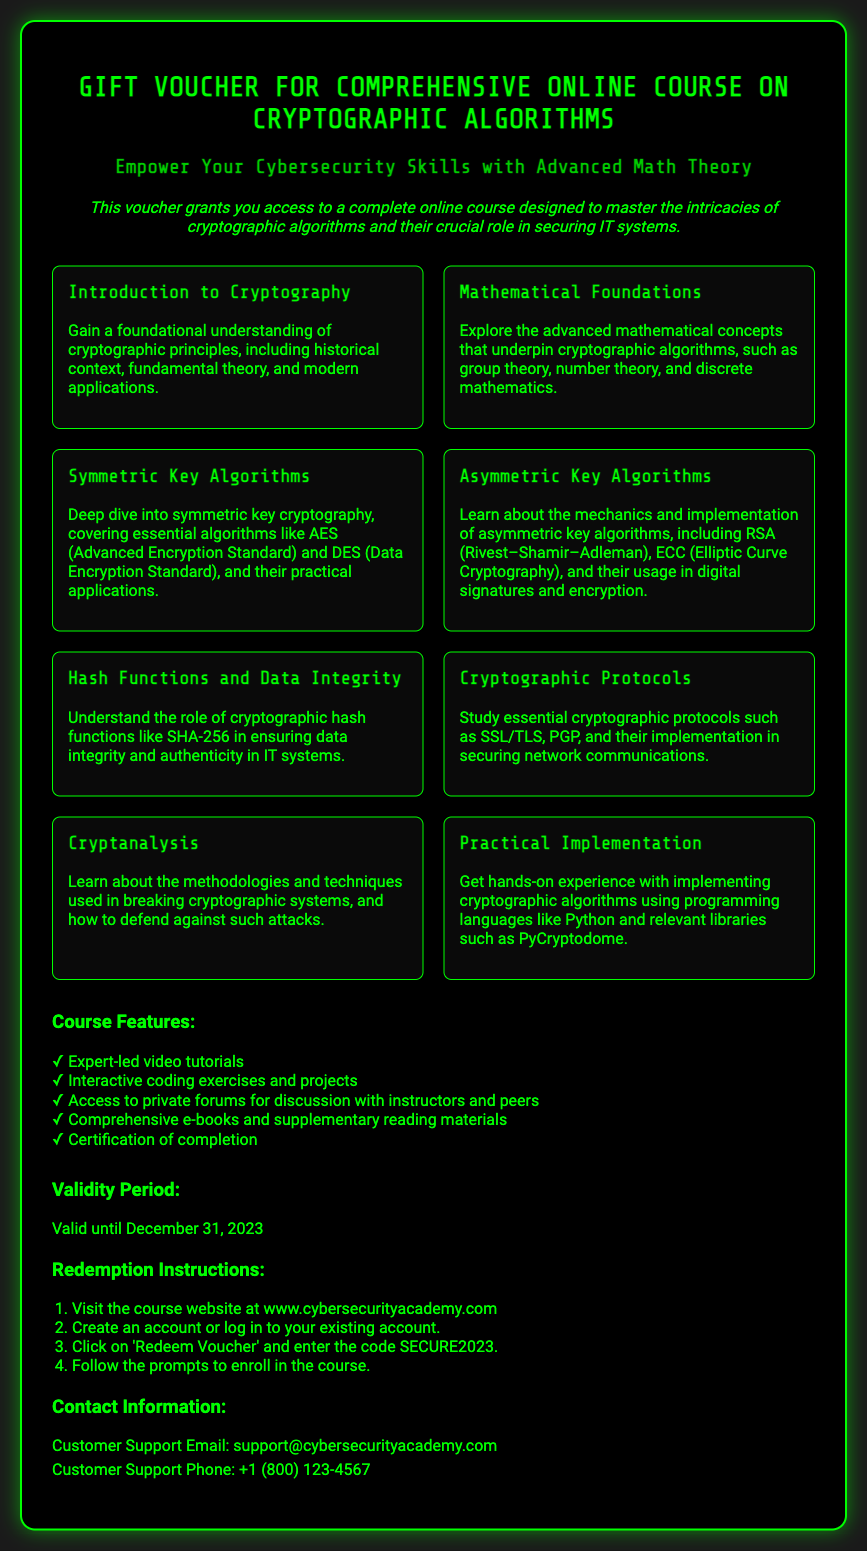What is the title of the course? The title of the course is specified at the top of the voucher document.
Answer: Gift Voucher for Comprehensive Online Course on Cryptographic Algorithms What is the code for redeeming the voucher? The redemption code is mentioned in the redemption instructions section.
Answer: SECURE2023 When does the voucher expire? The validity period of the voucher is stated in the validity section.
Answer: December 31, 2023 How many modules are included in the course? The number of distinct modules listed on the voucher provides the answer.
Answer: Eight What is one of the course features? The features are listed under the course features section, the question asks for one example.
Answer: Expert-led video tutorials Which mathematical concepts are explored in the course? The specific area related to mathematical concepts is mentioned among the modules.
Answer: Group theory, number theory, and discrete mathematics Where can the course be accessed? The website for the course is provided in the redemption instructions section.
Answer: www.cybersecurityacademy.com What is the support email for customer inquiries? Contact information for customer support is clearly stated in the contact section.
Answer: support@cybersecurityacademy.com 